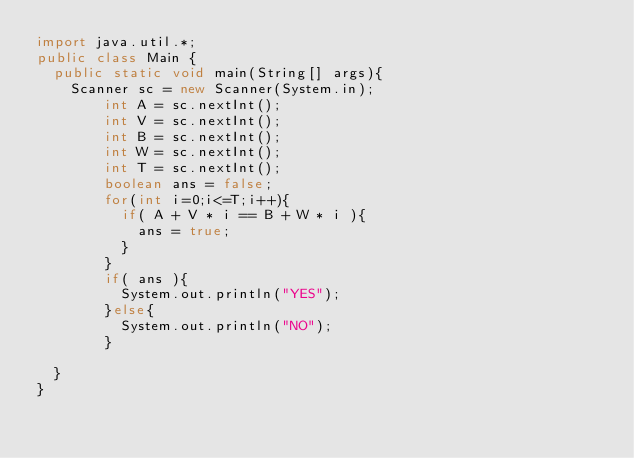Convert code to text. <code><loc_0><loc_0><loc_500><loc_500><_Java_>import java.util.*;
public class Main {
	public static void main(String[] args){
		Scanner sc = new Scanner(System.in);
      	int A = sc.nextInt();
        int V = sc.nextInt();
        int B = sc.nextInt();
        int W = sc.nextInt();
        int T = sc.nextInt();
      	boolean ans = false;
      	for(int i=0;i<=T;i++){
          if( A + V * i == B + W * i ){
            ans = true;
          }
        }
      	if( ans ){
          System.out.println("YES"); 
        }else{
          System.out.println("NO"); 
        }
      	   	
	}
}</code> 